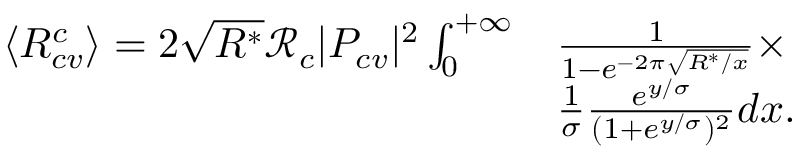<formula> <loc_0><loc_0><loc_500><loc_500>\begin{array} { r l } { \langle R _ { c v } ^ { c } \rangle = 2 \sqrt { R ^ { * } } \mathcal { R } _ { c } | P _ { c v } | ^ { 2 } \int _ { 0 } ^ { + \infty } } & { \frac { 1 } { 1 - e ^ { - 2 \pi \sqrt { R ^ { * } / x } } } \times } \\ & { \frac { 1 } { \sigma } \frac { e ^ { y / \sigma } } { ( 1 + e ^ { y / \sigma } ) ^ { 2 } } d x . } \end{array}</formula> 